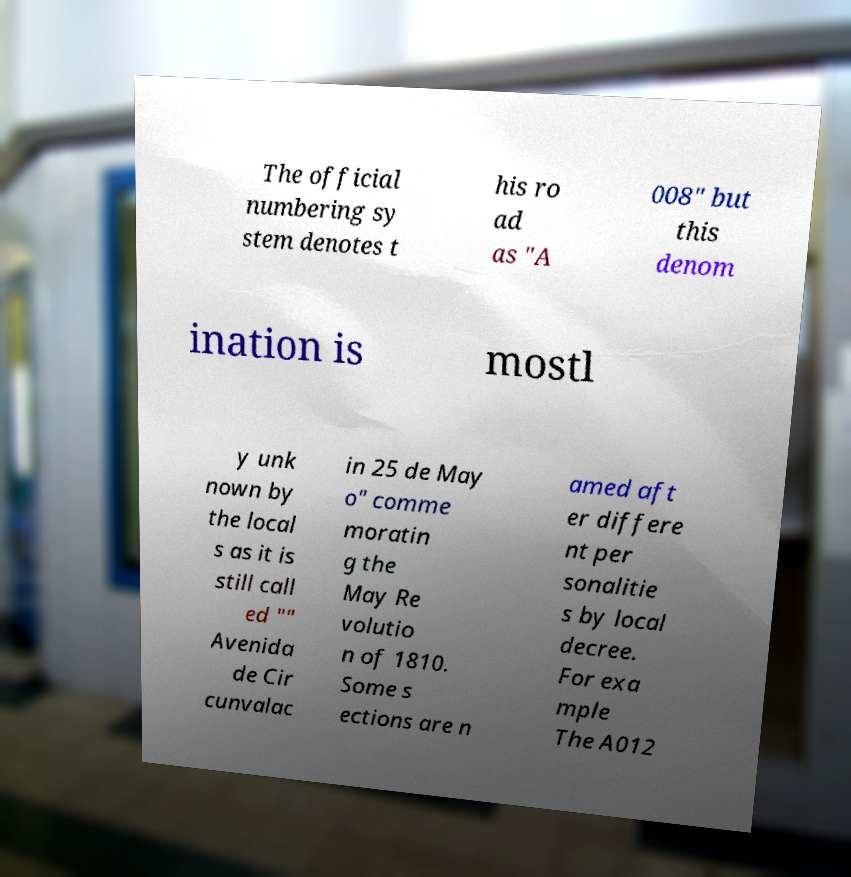Could you assist in decoding the text presented in this image and type it out clearly? The official numbering sy stem denotes t his ro ad as "A 008" but this denom ination is mostl y unk nown by the local s as it is still call ed "" Avenida de Cir cunvalac in 25 de May o" comme moratin g the May Re volutio n of 1810. Some s ections are n amed aft er differe nt per sonalitie s by local decree. For exa mple The A012 